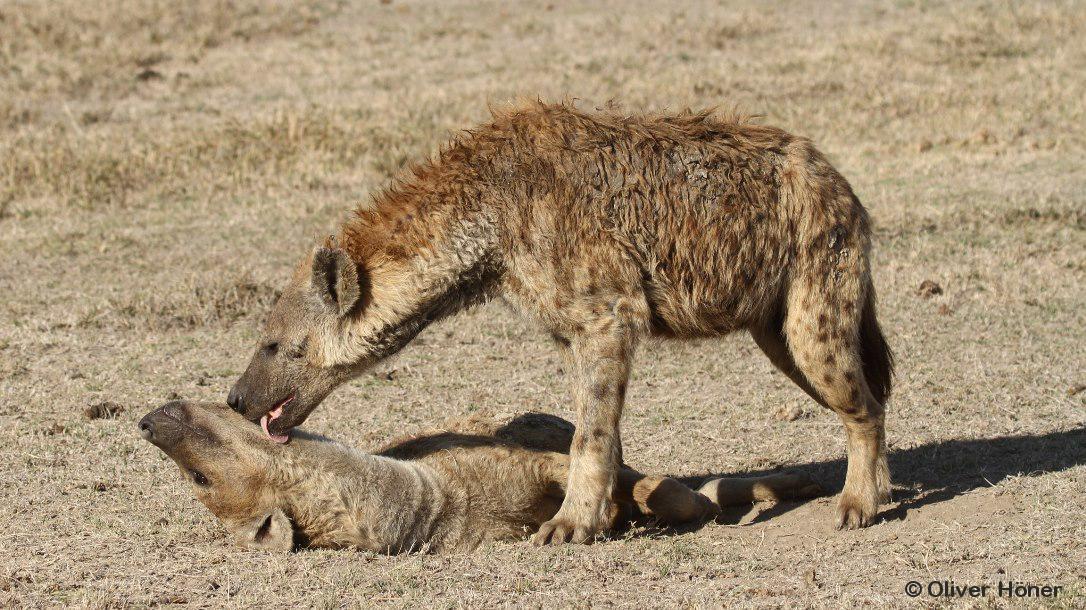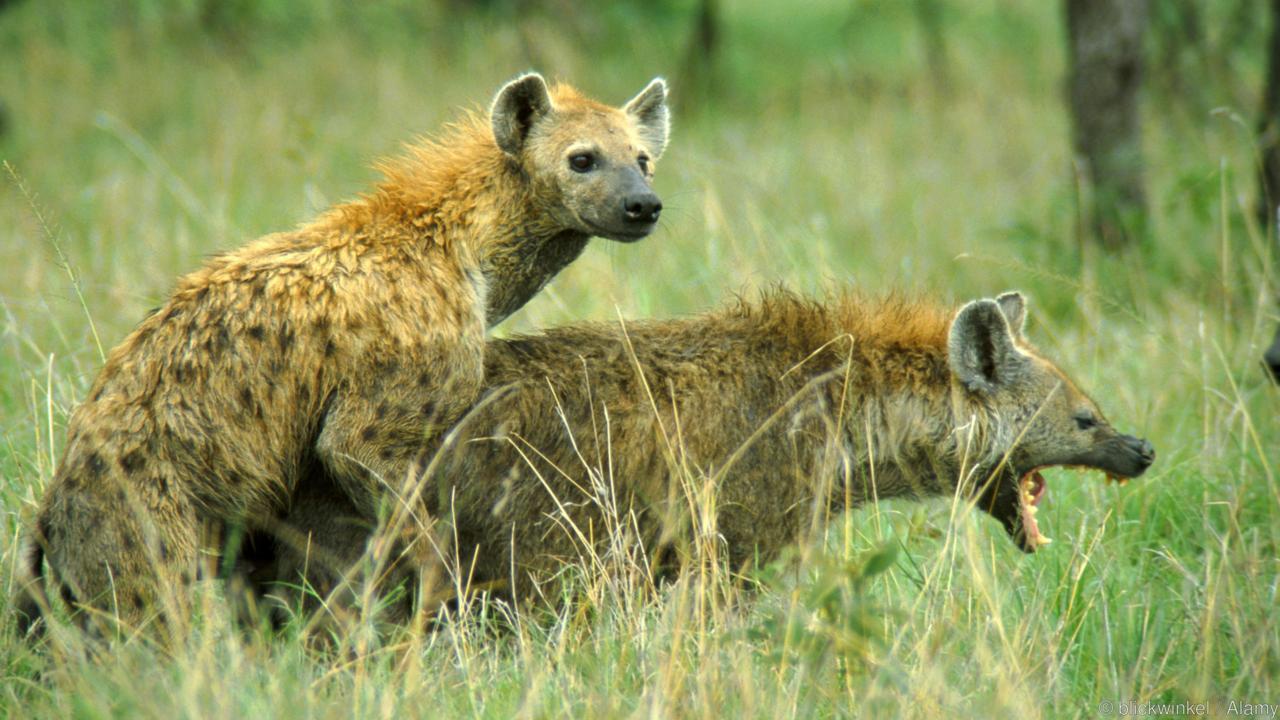The first image is the image on the left, the second image is the image on the right. Considering the images on both sides, is "There are two hyenas facing right." valid? Answer yes or no. Yes. 